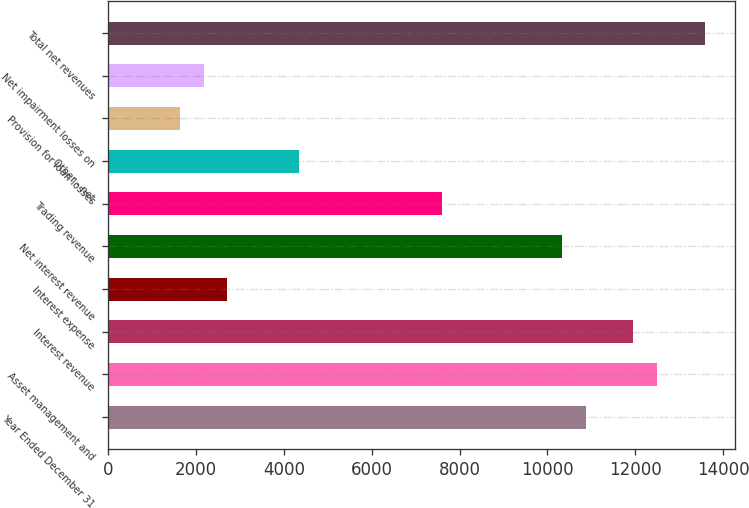Convert chart to OTSL. <chart><loc_0><loc_0><loc_500><loc_500><bar_chart><fcel>Year Ended December 31<fcel>Asset management and<fcel>Interest revenue<fcel>Interest expense<fcel>Net interest revenue<fcel>Trading revenue<fcel>Other - net<fcel>Provision for loan losses<fcel>Net impairment losses on<fcel>Total net revenues<nl><fcel>10869.8<fcel>12500.3<fcel>11956.8<fcel>2717.64<fcel>10326.4<fcel>7608.96<fcel>4348.08<fcel>1630.68<fcel>2174.16<fcel>13587.2<nl></chart> 